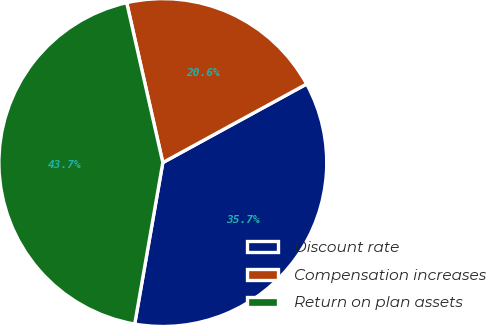Convert chart to OTSL. <chart><loc_0><loc_0><loc_500><loc_500><pie_chart><fcel>Discount rate<fcel>Compensation increases<fcel>Return on plan assets<nl><fcel>35.7%<fcel>20.58%<fcel>43.72%<nl></chart> 